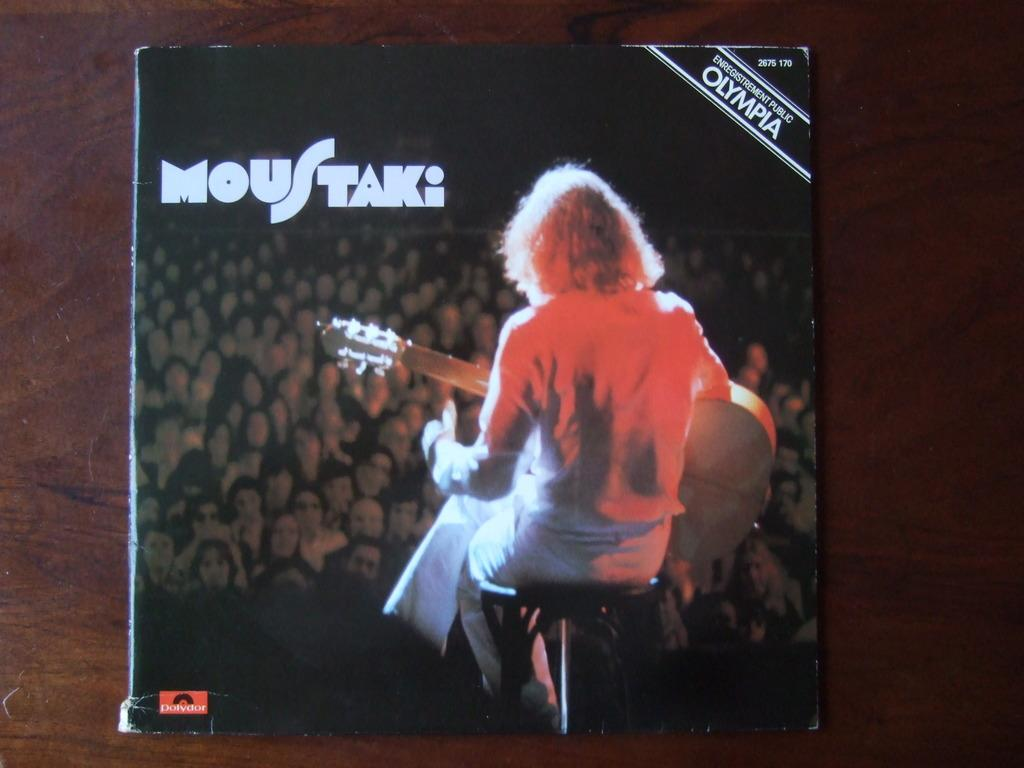<image>
Summarize the visual content of the image. A slightly worn cover of the album Moustak has an image of a woman sitting in front of a crowd, playing her guitar. 